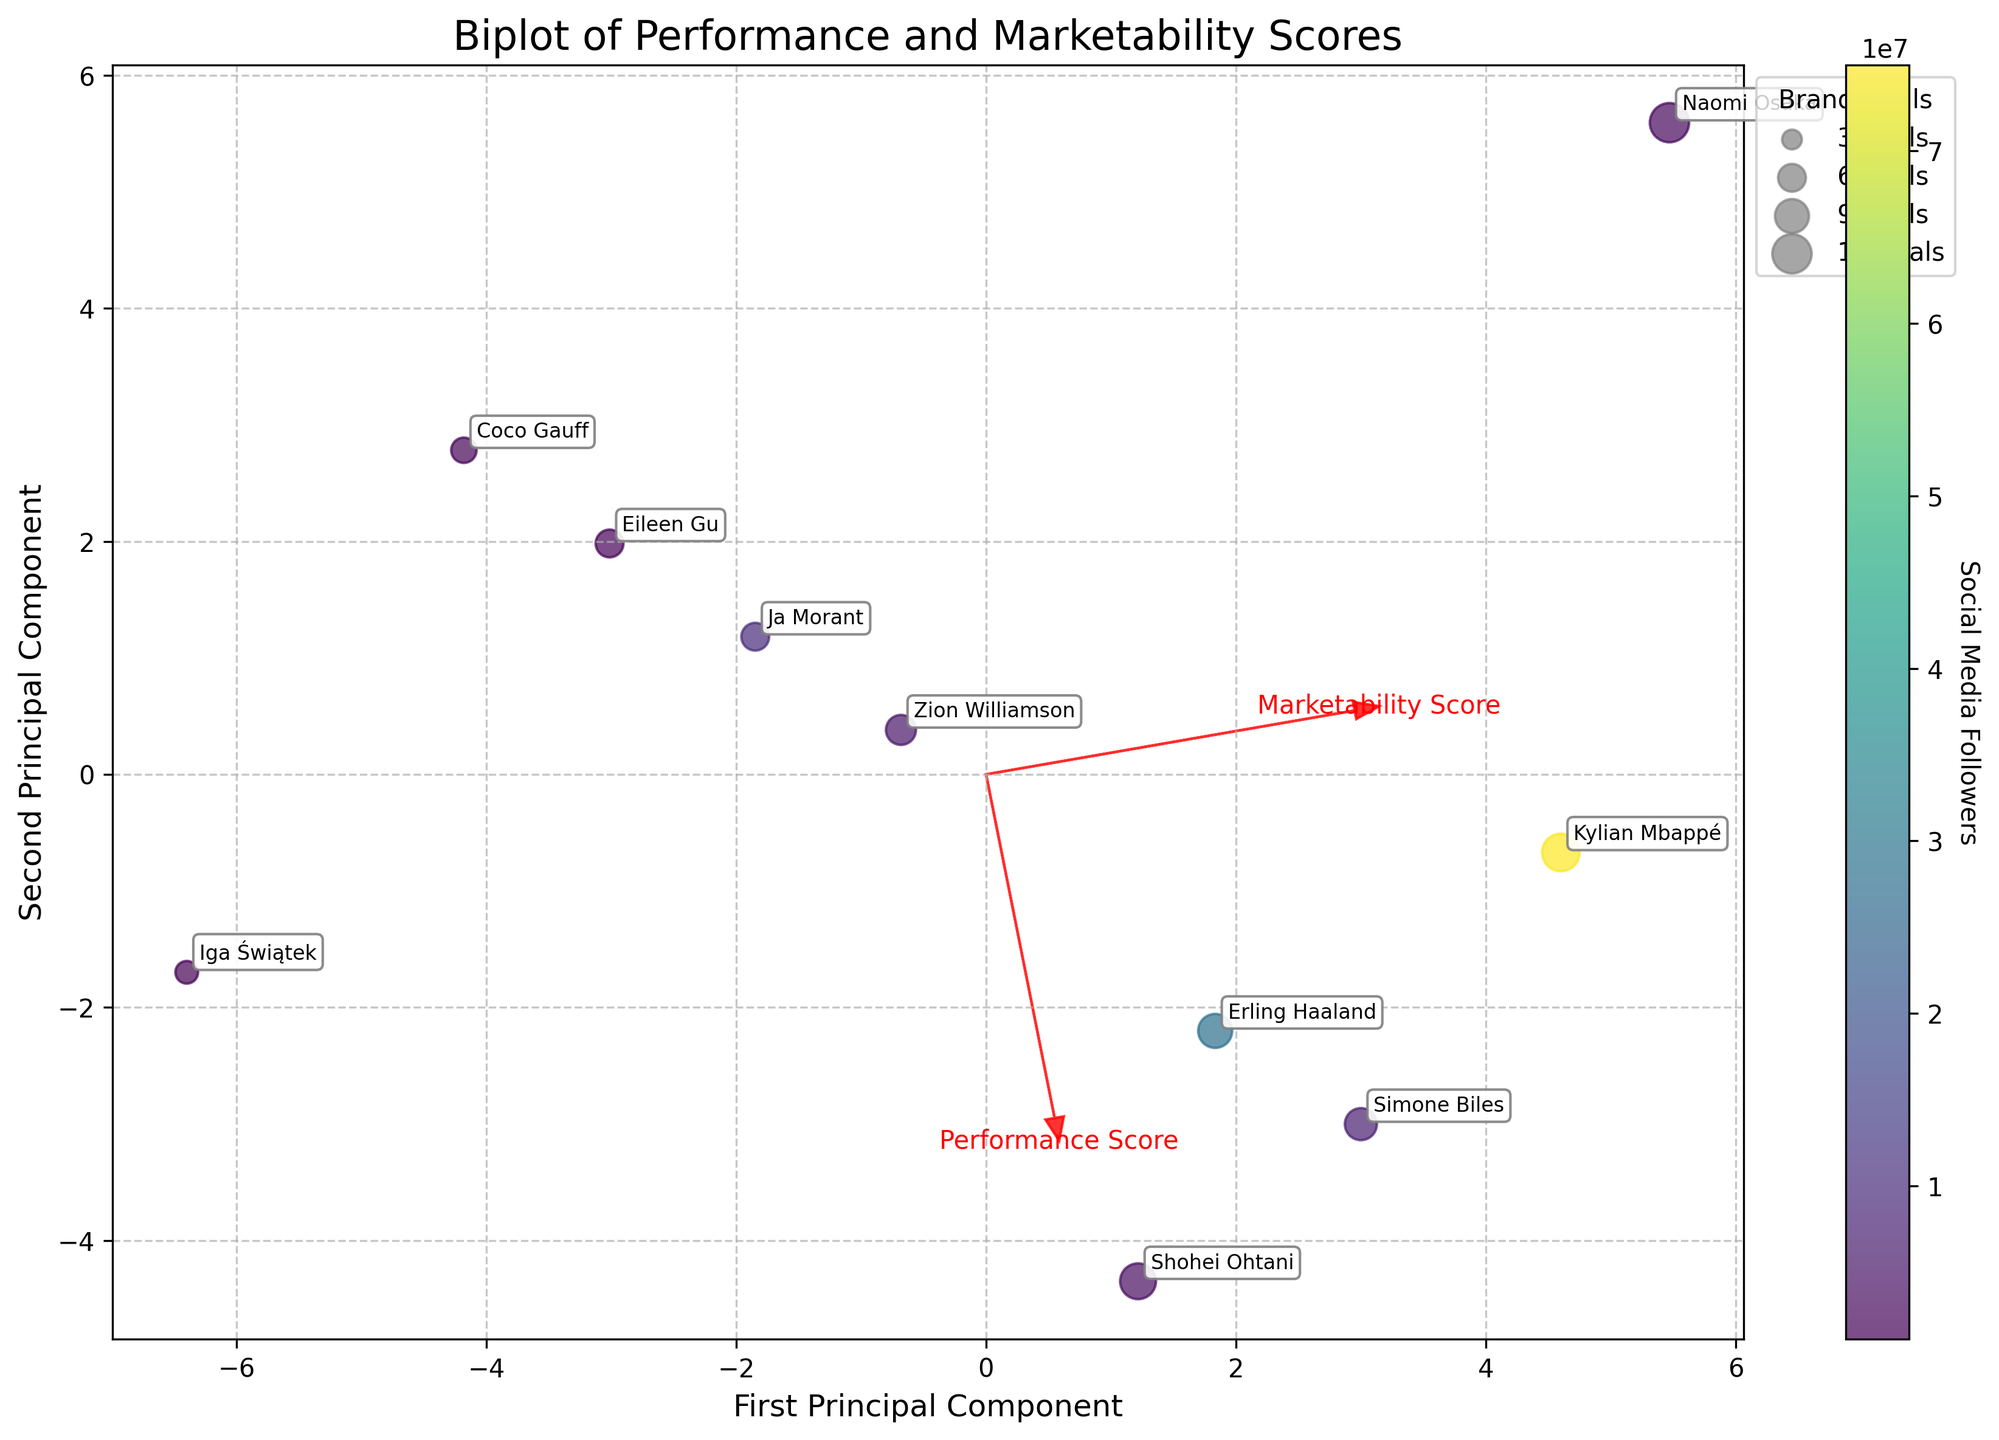What are the axes labels of the plot? The x-axis is labeled "First Principal Component," and the y-axis is labeled "Second Principal Component."
Answer: "First Principal Component" and "Second Principal Component" What does the color gradient in the scatter plot represent? The color gradient represents the number of Social Media Followers for each athlete. Darker colors indicate fewer followers, while lighter colors indicate more followers.
Answer: Social Media Followers Which athlete has the highest Performance Score projection on the first principal component? To find this, look for the athlete closest to the highest value on the first principal component (x-axis). "Shohei Ohtani" is positioned in the far right, suggesting the highest performance score projection.
Answer: Shohei Ohtani How many athletes are represented in the plot? Count the number of data points or labeled athletes in the scatter plot. There are 10 athletes shown.
Answer: 10 Which athlete has the most Brand Deals, and how is it represented on the plot? Naomi Osaka has the most Brand Deals, which is represented by the size of the data point being one of the largest.
Answer: Naomi Osaka What relationship do the arrows represent in the biplot? The arrows represent the contribution of each original feature (Performance Score and Marketability Score) to the principal components. They indicate the direction and magnitude of each feature.
Answer: Contribution of features to principal components How does the Marketability Score correlate with the second principal component? The arrow for the Marketability Score points mainly in the direction of the second principal component (y-axis). This means Marketability Score has a strong positive correlation with the second principal component.
Answer: Positively correlated Which athlete has a similar balance of Performance and Marketability Scores based on their position in the biplot? Check for an athlete near the origin or close to the diagonal line where Performance Score and Marketability Score contribute equally. "Coco Gauff" is positioned relatively close to this balance area.
Answer: Coco Gauff Who has the highest number of Social Media Followers and where are they located on the plot? Kylian Mbappé has the highest number of Social Media Followers, and he is located towards the upper right of the plot.
Answer: Kylian Mbappé Rank the athletes by their Performance Score projection on the first principal component from highest to lowest. Rank the athletes by their relative positions along the x-axis. Shohei Ohtani, Simone Biles, Erling Haaland, Kylian Mbappé, Iga Świątek, Zion Williamson, Ja Morant, Eileen Gu, Coco Gauff, Naomi Osaka.
Answer: Shohei Ohtani, Simone Biles, Erling Haaland, Kylian Mbappé, Iga Świątek, Zion Williamson, Ja Morant, Eileen Gu, Coco Gauff, Naomi Osaka 